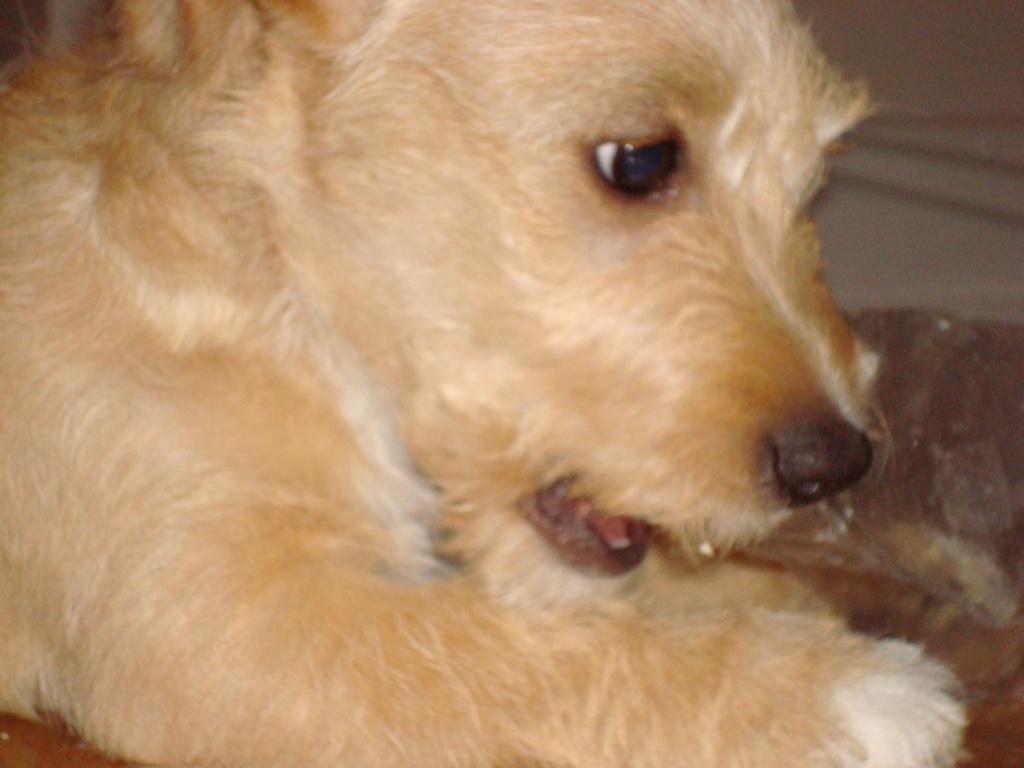Could you give a brief overview of what you see in this image? As we can see in the image there is a cream color dog. 